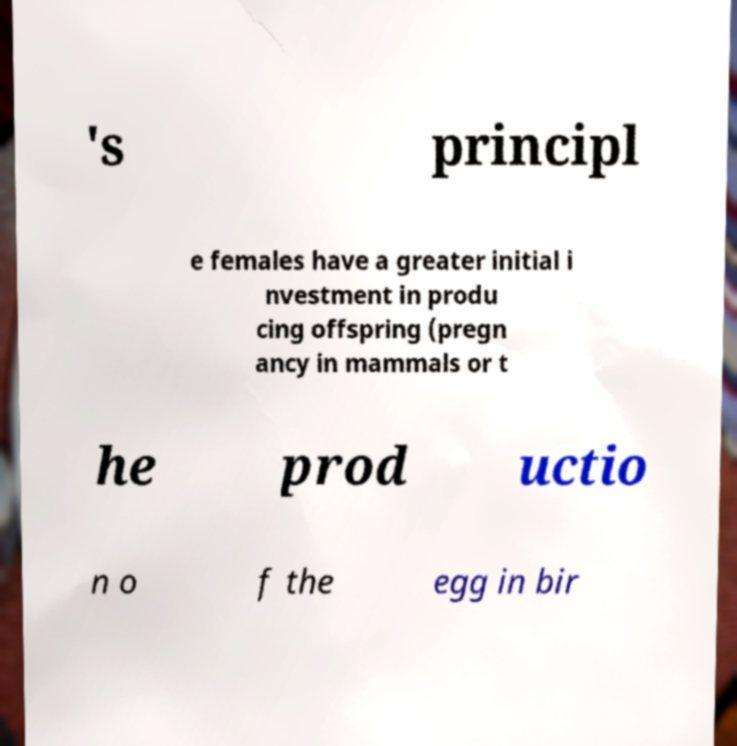There's text embedded in this image that I need extracted. Can you transcribe it verbatim? 's principl e females have a greater initial i nvestment in produ cing offspring (pregn ancy in mammals or t he prod uctio n o f the egg in bir 